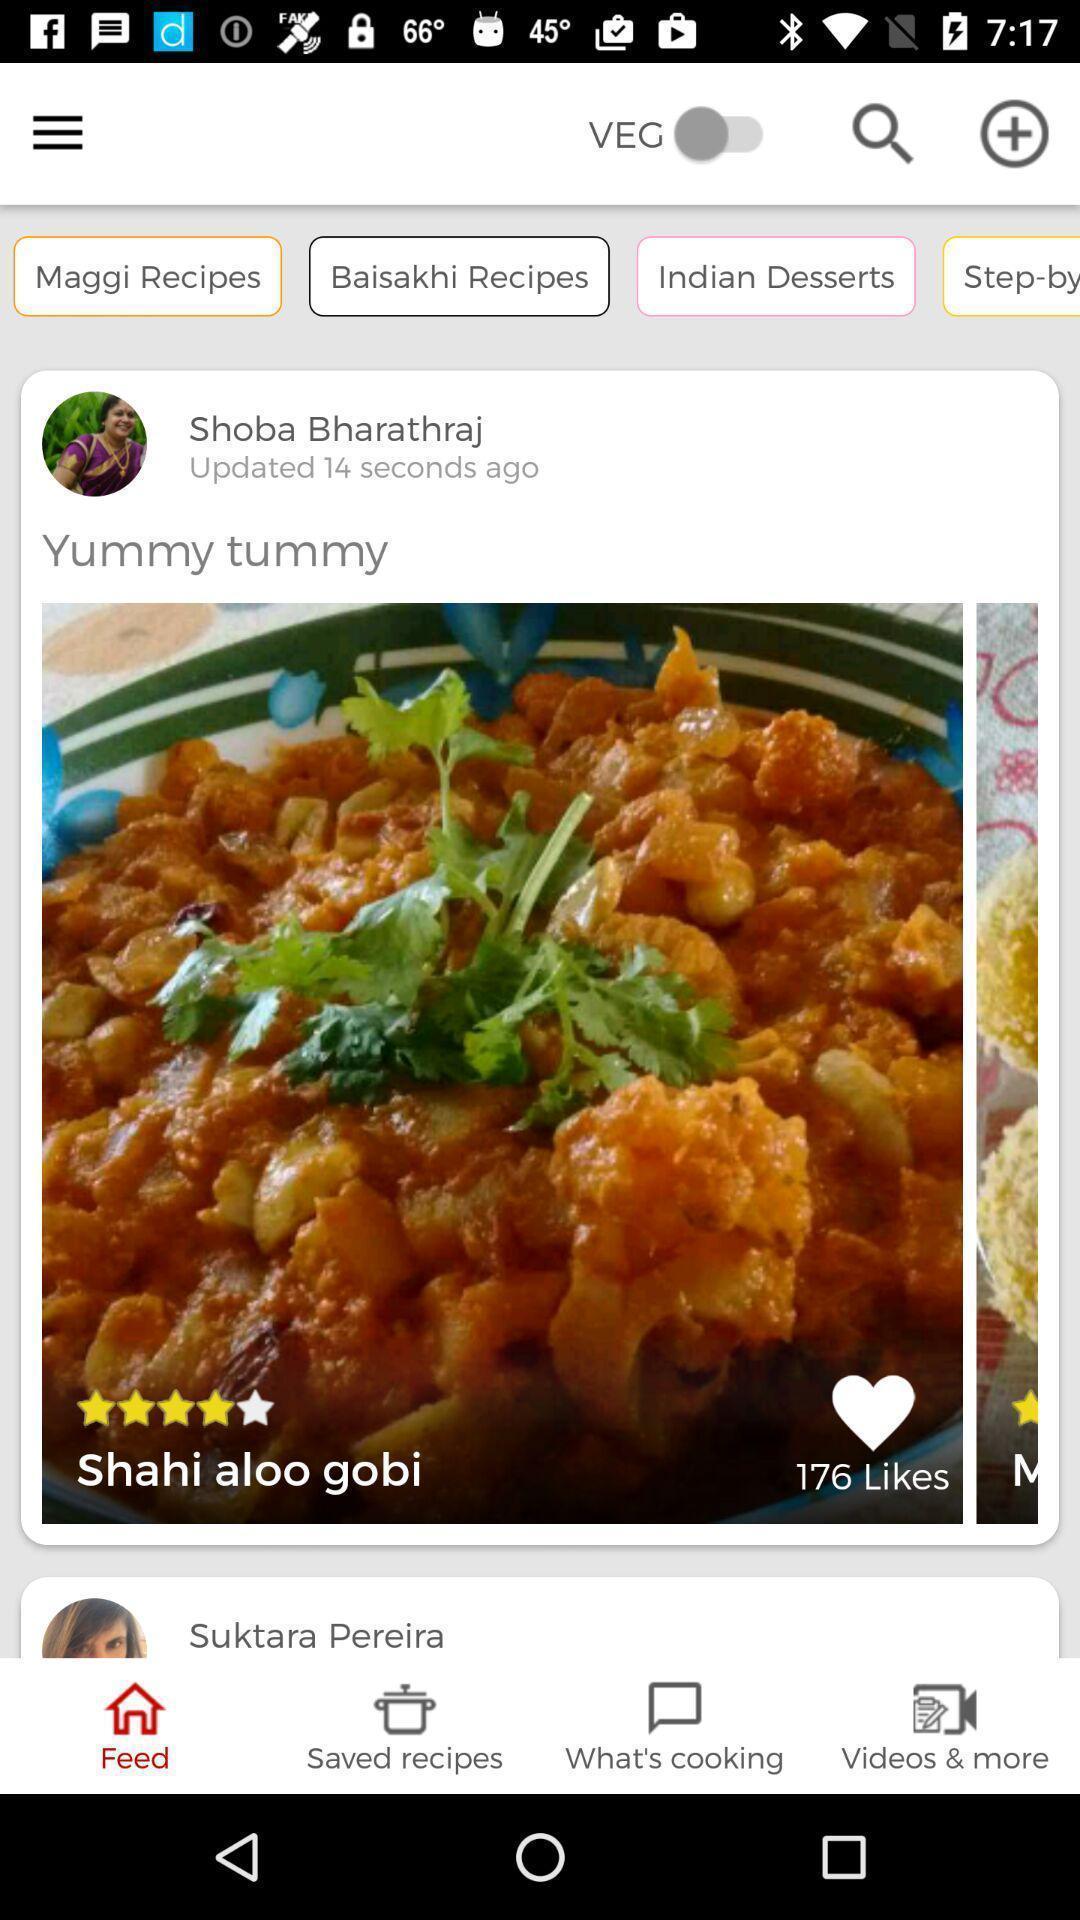What can you discern from this picture? Screen displaying food images in a recipe application. 